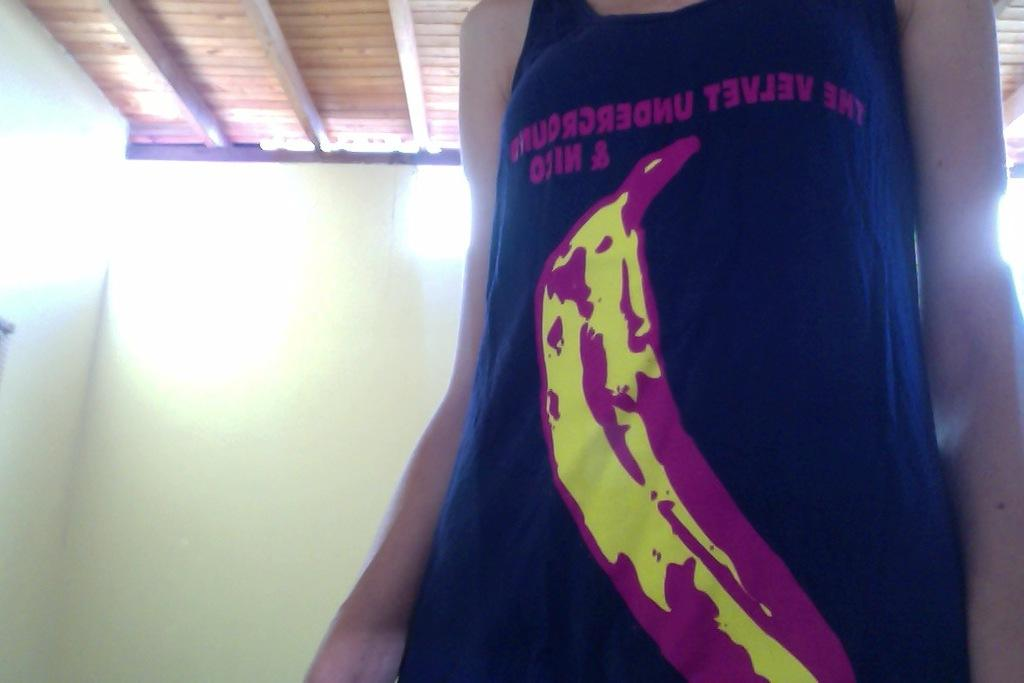Provide a one-sentence caption for the provided image. A woman whose head you cannot see wears a black sleevless shirt with The Velvet Underground on it. 